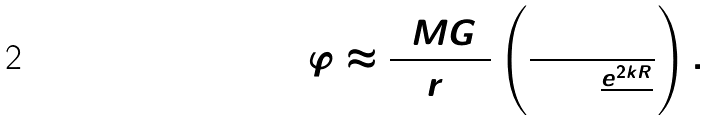Convert formula to latex. <formula><loc_0><loc_0><loc_500><loc_500>\Delta \varphi \approx \frac { 4 M G _ { 2 } } { r _ { 0 } } \left ( \frac { 1 } { 1 + \frac { e ^ { 2 k R } } { 3 } } \right ) .</formula> 